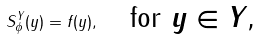<formula> <loc_0><loc_0><loc_500><loc_500>S _ { \phi } ^ { Y } ( y ) = f ( y ) , \quad \text {for $y \in Y$,}</formula> 